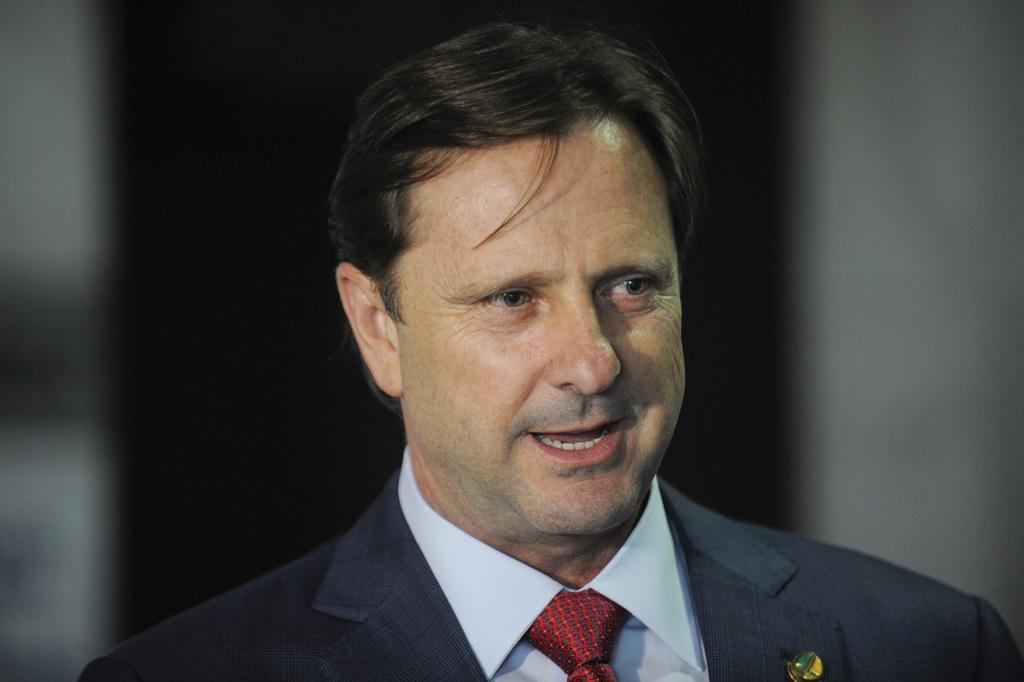In one or two sentences, can you explain what this image depicts? In this image I can see a person wearing shirt, tie and blazer and I can see the blurry background. 